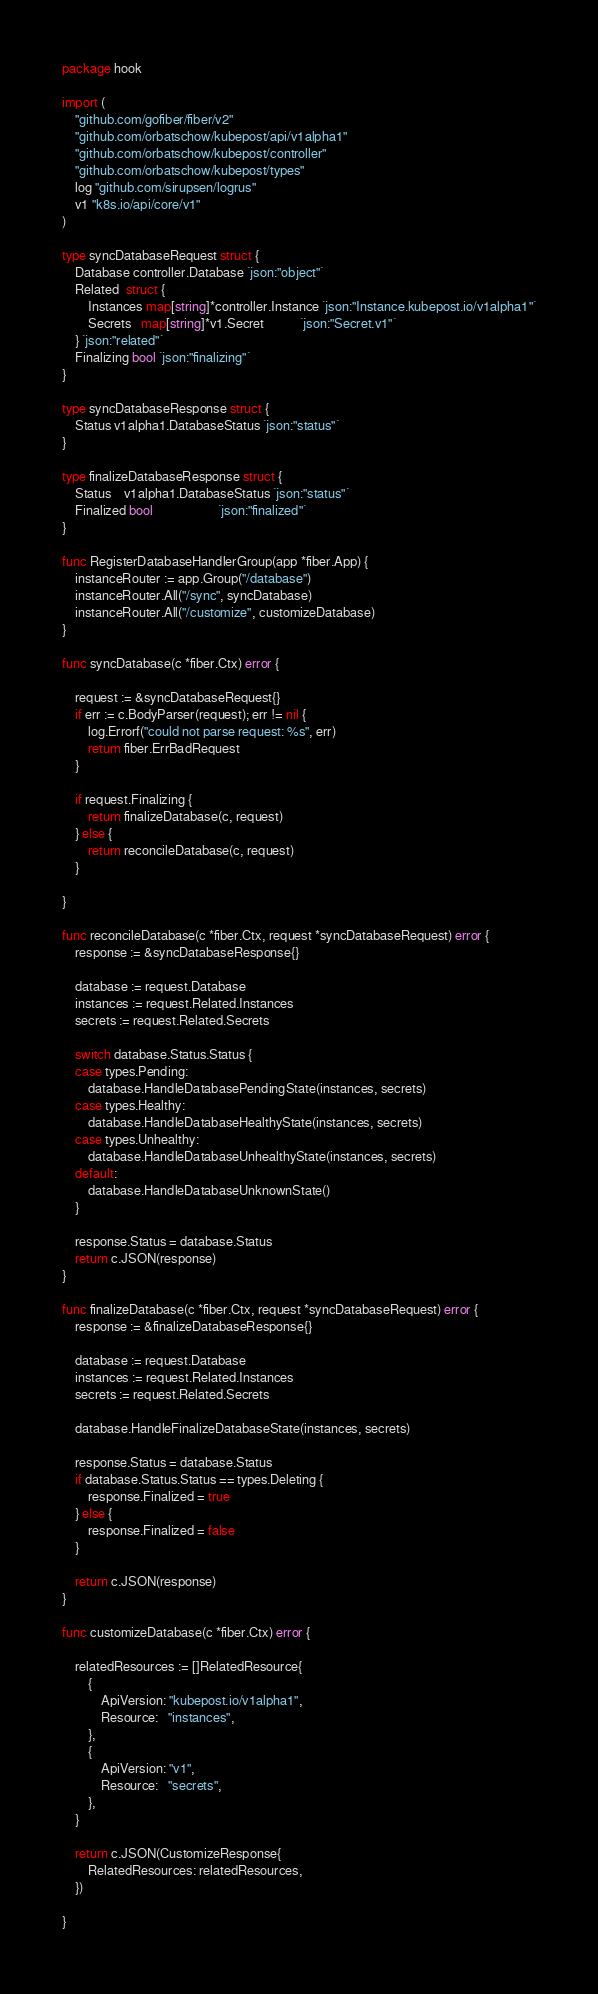<code> <loc_0><loc_0><loc_500><loc_500><_Go_>package hook

import (
    "github.com/gofiber/fiber/v2"
    "github.com/orbatschow/kubepost/api/v1alpha1"
    "github.com/orbatschow/kubepost/controller"
    "github.com/orbatschow/kubepost/types"
    log "github.com/sirupsen/logrus"
    v1 "k8s.io/api/core/v1"
)

type syncDatabaseRequest struct {
    Database controller.Database `json:"object"`
    Related  struct {
        Instances map[string]*controller.Instance `json:"Instance.kubepost.io/v1alpha1"`
        Secrets   map[string]*v1.Secret           `json:"Secret.v1"`
    } `json:"related"`
    Finalizing bool `json:"finalizing"`
}

type syncDatabaseResponse struct {
    Status v1alpha1.DatabaseStatus `json:"status"`
}

type finalizeDatabaseResponse struct {
    Status    v1alpha1.DatabaseStatus `json:"status"`
    Finalized bool                    `json:"finalized"`
}

func RegisterDatabaseHandlerGroup(app *fiber.App) {
    instanceRouter := app.Group("/database")
    instanceRouter.All("/sync", syncDatabase)
    instanceRouter.All("/customize", customizeDatabase)
}

func syncDatabase(c *fiber.Ctx) error {

    request := &syncDatabaseRequest{}
    if err := c.BodyParser(request); err != nil {
        log.Errorf("could not parse request: %s", err)
        return fiber.ErrBadRequest
    }

    if request.Finalizing {
        return finalizeDatabase(c, request)
    } else {
        return reconcileDatabase(c, request)
    }

}

func reconcileDatabase(c *fiber.Ctx, request *syncDatabaseRequest) error {
    response := &syncDatabaseResponse{}

    database := request.Database
    instances := request.Related.Instances
    secrets := request.Related.Secrets

    switch database.Status.Status {
    case types.Pending:
        database.HandleDatabasePendingState(instances, secrets)
    case types.Healthy:
        database.HandleDatabaseHealthyState(instances, secrets)
    case types.Unhealthy:
        database.HandleDatabaseUnhealthyState(instances, secrets)
    default:
        database.HandleDatabaseUnknownState()
    }

    response.Status = database.Status
    return c.JSON(response)
}

func finalizeDatabase(c *fiber.Ctx, request *syncDatabaseRequest) error {
    response := &finalizeDatabaseResponse{}

    database := request.Database
    instances := request.Related.Instances
    secrets := request.Related.Secrets

    database.HandleFinalizeDatabaseState(instances, secrets)

    response.Status = database.Status
    if database.Status.Status == types.Deleting {
        response.Finalized = true
    } else {
        response.Finalized = false
    }

    return c.JSON(response)
}

func customizeDatabase(c *fiber.Ctx) error {

    relatedResources := []RelatedResource{
        {
            ApiVersion: "kubepost.io/v1alpha1",
            Resource:   "instances",
        },
        {
            ApiVersion: "v1",
            Resource:   "secrets",
        },
    }

    return c.JSON(CustomizeResponse{
        RelatedResources: relatedResources,
    })

}
</code> 